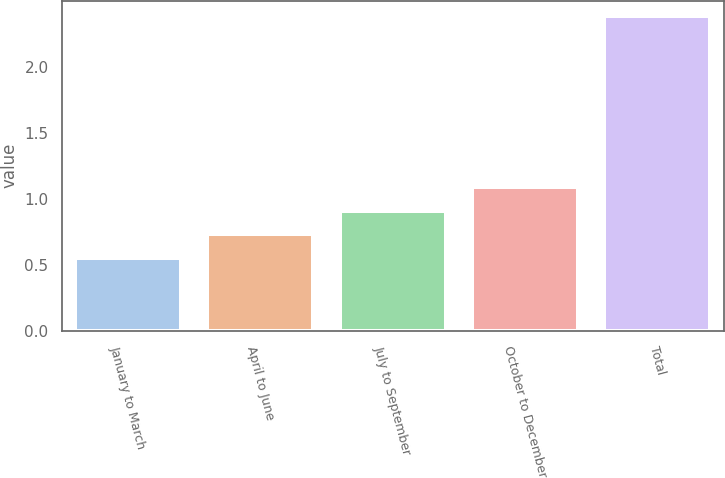<chart> <loc_0><loc_0><loc_500><loc_500><bar_chart><fcel>January to March<fcel>April to June<fcel>July to September<fcel>October to December<fcel>Total<nl><fcel>0.55<fcel>0.73<fcel>0.91<fcel>1.09<fcel>2.38<nl></chart> 